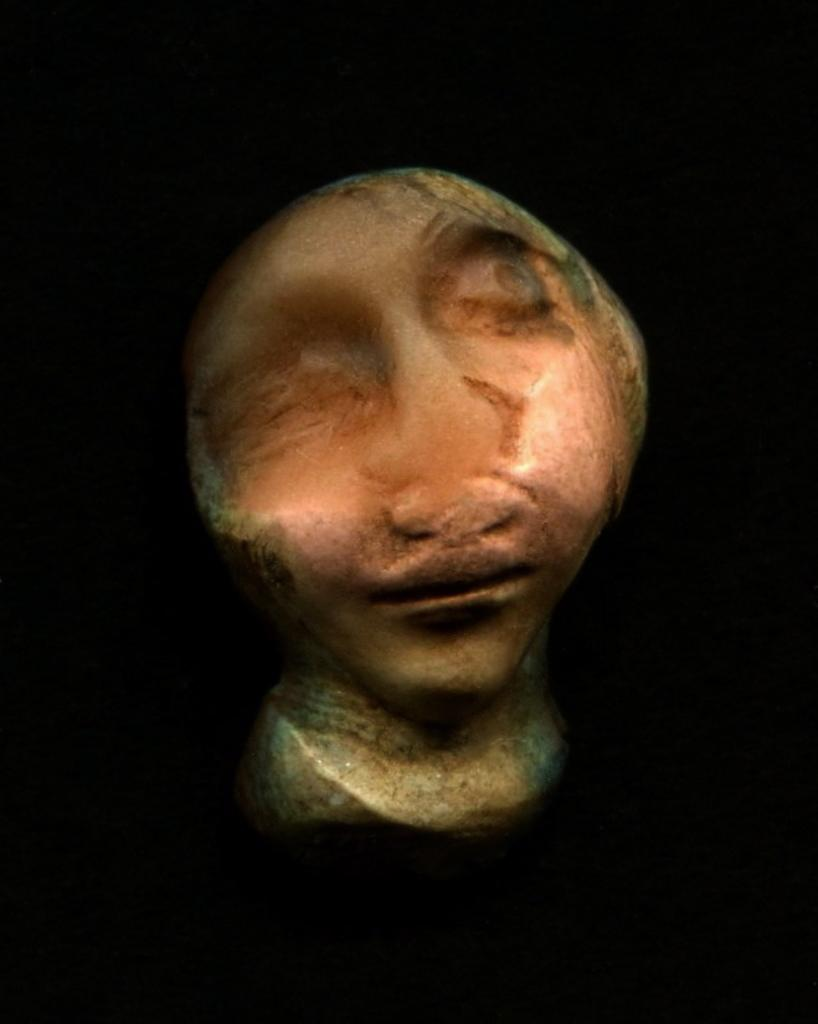What is the main subject in the image? There is a bust in the image. What type of pan is being traded for the bust in the image? There is no pan or trade present in the image; it only features a bust. 